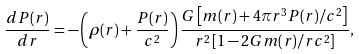<formula> <loc_0><loc_0><loc_500><loc_500>\frac { d P ( r ) } { d r } = - \left ( \rho ( r ) + \frac { P ( r ) } { c ^ { 2 } } \right ) \frac { G \left [ m ( r ) + 4 \pi r ^ { 3 } P ( r ) / c ^ { 2 } \right ] } { r ^ { 2 } \left [ 1 - 2 G m ( r ) / r c ^ { 2 } \right ] } ,</formula> 